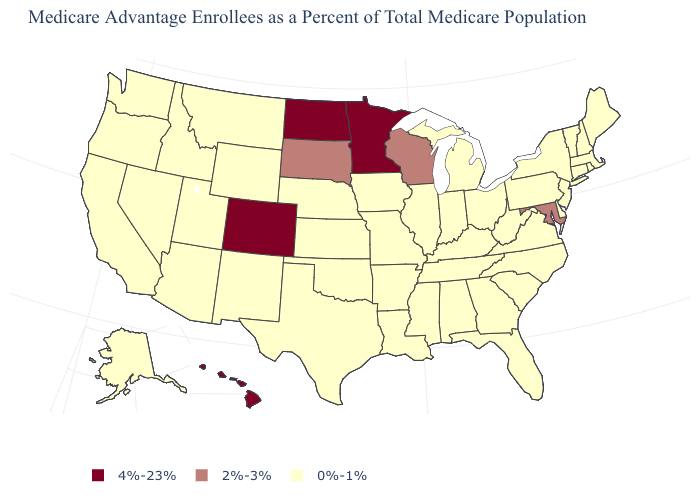How many symbols are there in the legend?
Answer briefly. 3. Does Colorado have the highest value in the USA?
Quick response, please. Yes. Does the first symbol in the legend represent the smallest category?
Give a very brief answer. No. Among the states that border Pennsylvania , which have the lowest value?
Keep it brief. Delaware, New Jersey, New York, Ohio, West Virginia. What is the lowest value in the Northeast?
Answer briefly. 0%-1%. What is the value of Hawaii?
Answer briefly. 4%-23%. Name the states that have a value in the range 2%-3%?
Concise answer only. Maryland, South Dakota, Wisconsin. What is the highest value in the USA?
Write a very short answer. 4%-23%. Does Delaware have a lower value than New Mexico?
Answer briefly. No. Does Wisconsin have a lower value than Michigan?
Write a very short answer. No. Name the states that have a value in the range 4%-23%?
Answer briefly. Colorado, Hawaii, Minnesota, North Dakota. What is the lowest value in the USA?
Give a very brief answer. 0%-1%. Which states have the highest value in the USA?
Give a very brief answer. Colorado, Hawaii, Minnesota, North Dakota. Which states have the lowest value in the USA?
Keep it brief. Alaska, Alabama, Arkansas, Arizona, California, Connecticut, Delaware, Florida, Georgia, Iowa, Idaho, Illinois, Indiana, Kansas, Kentucky, Louisiana, Massachusetts, Maine, Michigan, Missouri, Mississippi, Montana, North Carolina, Nebraska, New Hampshire, New Jersey, New Mexico, Nevada, New York, Ohio, Oklahoma, Oregon, Pennsylvania, Rhode Island, South Carolina, Tennessee, Texas, Utah, Virginia, Vermont, Washington, West Virginia, Wyoming. 